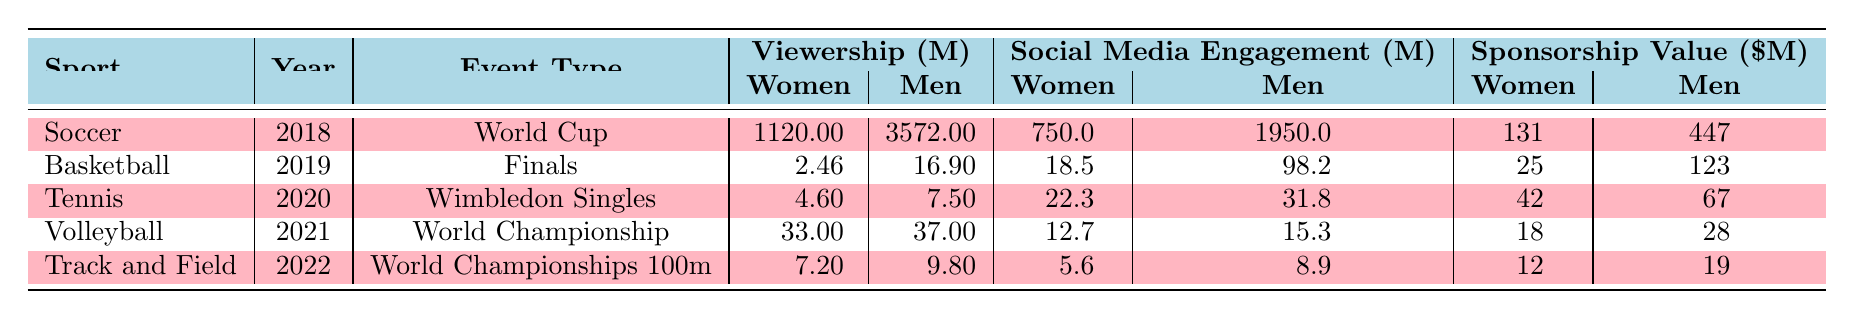What is the viewership for the FIFA Women's World Cup in millions? According to the table, the viewership for the FIFA Women's World Cup in 2018 is 1120 million.
Answer: 1120 million What was the women's viewership for the WNBA Finals in 2019? The table shows that the viewership for the WNBA Finals in 2019 is 2.46 million.
Answer: 2.46 million Which sport had the highest women's viewership in 2022? Looking at the viewership values for women's events in the table, the World Athletics Championships Women's 100m had the highest viewership at 7.2 million.
Answer: 7.2 million What is the difference in social media engagement between women's and men's events in 2021 for Volleyball? For Volleyball in 2021, women's social media engagement is 12.7 million and men's is 15.3 million. The difference is 15.3 - 12.7 = 2.6 million.
Answer: 2.6 million What event had the lowest sponsorship value for women and what was that value? The lowest sponsorship value for women in the table is for Track and Field, which is 12 million.
Answer: 12 million Did the men's FIFA World Cup have a higher viewership than the women's FIFA World Cup in 2018? Yes, the men's FIFA World Cup had a viewership of 3572 million, which is higher than the women's viewership of 1120 million.
Answer: Yes What was the average viewership for women's events over the five years listed? To find the average, sum the women's viewership values: 1120 + 2.46 + 4.6 + 33 + 7.2 = 1167.26 million. Then divide by 5 (the number of years): 1167.26 / 5 = 233.452 million.
Answer: 233.452 million How much more sponsorship value did the men's NBA Finals have compared to the women's WNBA Finals in 2019? The men's NBA Finals had a sponsorship value of 123 million, while the women's WNBA Finals had a value of 25 million. The difference is 123 - 25 = 98 million.
Answer: 98 million Is the sponsorship value for the Women's FIFA World Cup higher than the sponsorship value for the Men's FIFA World Cup? No, the Women's FIFA World Cup sponsorship value is 131 million, while the Men's is 447 million.
Answer: No In which year did the event with the highest women's viewership occur? The highest women's viewership is for the FIFA Women's World Cup in 2018 with 1120 million. Thus, the year is 2018.
Answer: 2018 